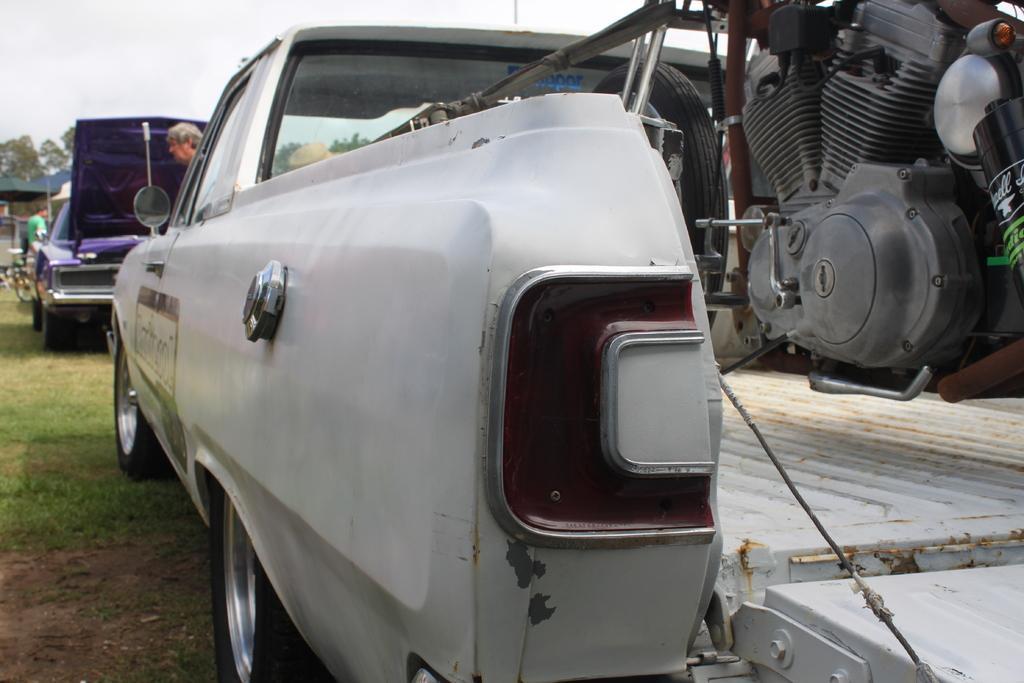Describe this image in one or two sentences. In the foreground of this picture, there is a bike in a van. In the background, there is a purple car, a man, trees, tents, bicycle, grass, and the sky. 